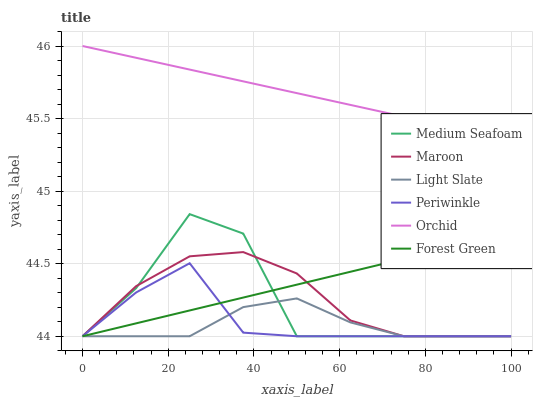Does Light Slate have the minimum area under the curve?
Answer yes or no. Yes. Does Orchid have the maximum area under the curve?
Answer yes or no. Yes. Does Maroon have the minimum area under the curve?
Answer yes or no. No. Does Maroon have the maximum area under the curve?
Answer yes or no. No. Is Orchid the smoothest?
Answer yes or no. Yes. Is Medium Seafoam the roughest?
Answer yes or no. Yes. Is Maroon the smoothest?
Answer yes or no. No. Is Maroon the roughest?
Answer yes or no. No. Does Orchid have the lowest value?
Answer yes or no. No. Does Maroon have the highest value?
Answer yes or no. No. Is Forest Green less than Orchid?
Answer yes or no. Yes. Is Orchid greater than Medium Seafoam?
Answer yes or no. Yes. Does Forest Green intersect Orchid?
Answer yes or no. No. 